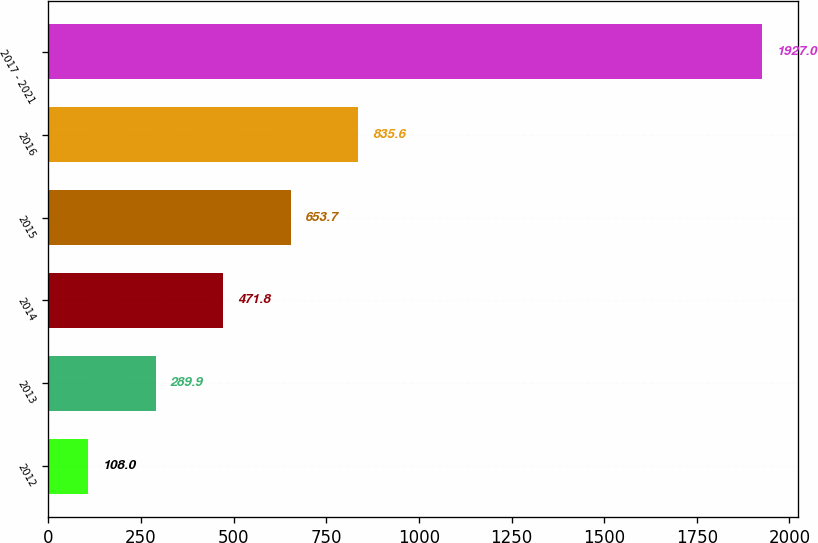<chart> <loc_0><loc_0><loc_500><loc_500><bar_chart><fcel>2012<fcel>2013<fcel>2014<fcel>2015<fcel>2016<fcel>2017 - 2021<nl><fcel>108<fcel>289.9<fcel>471.8<fcel>653.7<fcel>835.6<fcel>1927<nl></chart> 